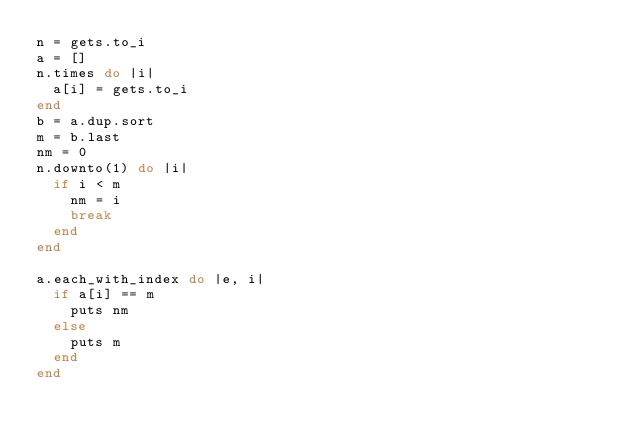<code> <loc_0><loc_0><loc_500><loc_500><_Ruby_>n = gets.to_i
a = []
n.times do |i|
  a[i] = gets.to_i
end
b = a.dup.sort
m = b.last
nm = 0
n.downto(1) do |i|
  if i < m
    nm = i
    break
  end
end

a.each_with_index do |e, i|
  if a[i] == m
    puts nm
  else
    puts m
  end
end</code> 